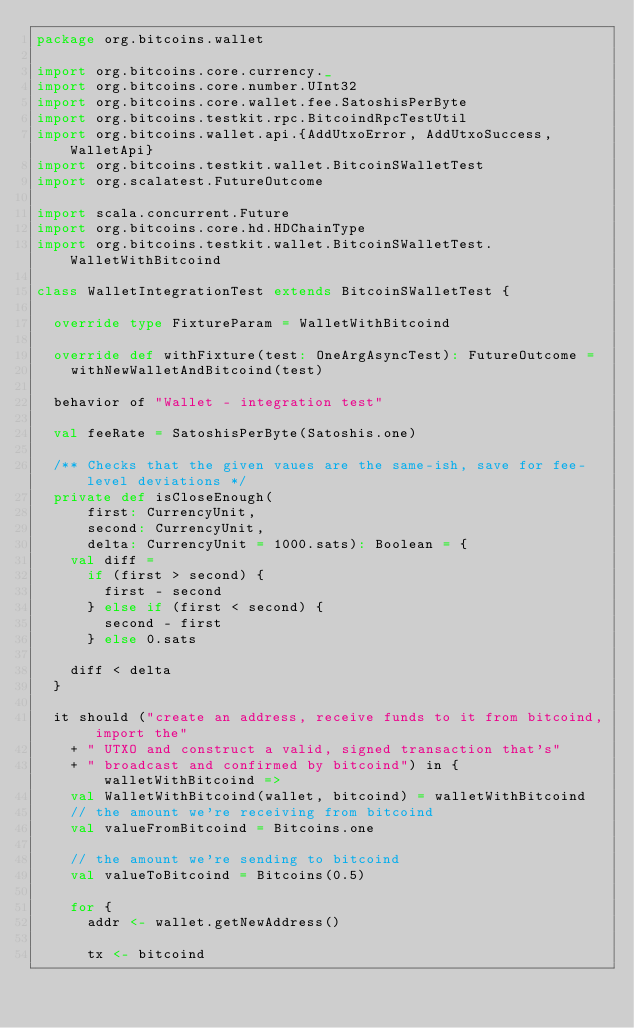Convert code to text. <code><loc_0><loc_0><loc_500><loc_500><_Scala_>package org.bitcoins.wallet

import org.bitcoins.core.currency._
import org.bitcoins.core.number.UInt32
import org.bitcoins.core.wallet.fee.SatoshisPerByte
import org.bitcoins.testkit.rpc.BitcoindRpcTestUtil
import org.bitcoins.wallet.api.{AddUtxoError, AddUtxoSuccess, WalletApi}
import org.bitcoins.testkit.wallet.BitcoinSWalletTest
import org.scalatest.FutureOutcome

import scala.concurrent.Future
import org.bitcoins.core.hd.HDChainType
import org.bitcoins.testkit.wallet.BitcoinSWalletTest.WalletWithBitcoind

class WalletIntegrationTest extends BitcoinSWalletTest {

  override type FixtureParam = WalletWithBitcoind

  override def withFixture(test: OneArgAsyncTest): FutureOutcome =
    withNewWalletAndBitcoind(test)

  behavior of "Wallet - integration test"

  val feeRate = SatoshisPerByte(Satoshis.one)

  /** Checks that the given vaues are the same-ish, save for fee-level deviations */
  private def isCloseEnough(
      first: CurrencyUnit,
      second: CurrencyUnit,
      delta: CurrencyUnit = 1000.sats): Boolean = {
    val diff =
      if (first > second) {
        first - second
      } else if (first < second) {
        second - first
      } else 0.sats

    diff < delta
  }

  it should ("create an address, receive funds to it from bitcoind, import the"
    + " UTXO and construct a valid, signed transaction that's"
    + " broadcast and confirmed by bitcoind") in { walletWithBitcoind =>
    val WalletWithBitcoind(wallet, bitcoind) = walletWithBitcoind
    // the amount we're receiving from bitcoind
    val valueFromBitcoind = Bitcoins.one

    // the amount we're sending to bitcoind
    val valueToBitcoind = Bitcoins(0.5)

    for {
      addr <- wallet.getNewAddress()

      tx <- bitcoind</code> 